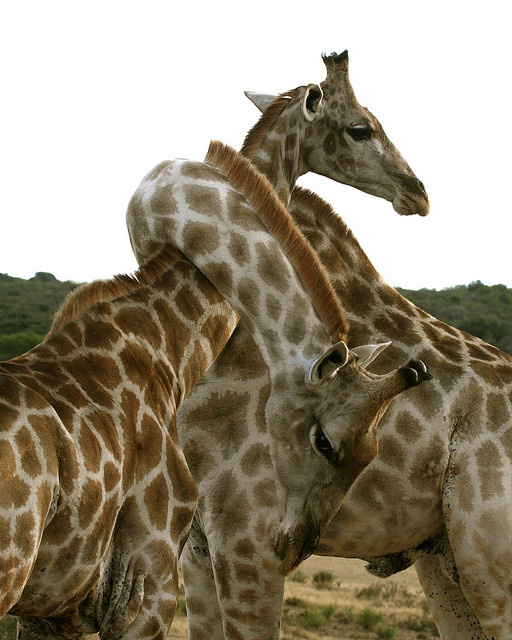Describe the objects in this image and their specific colors. I can see giraffe in white, olive, gray, and black tones and giraffe in white, olive, black, maroon, and gray tones in this image. 